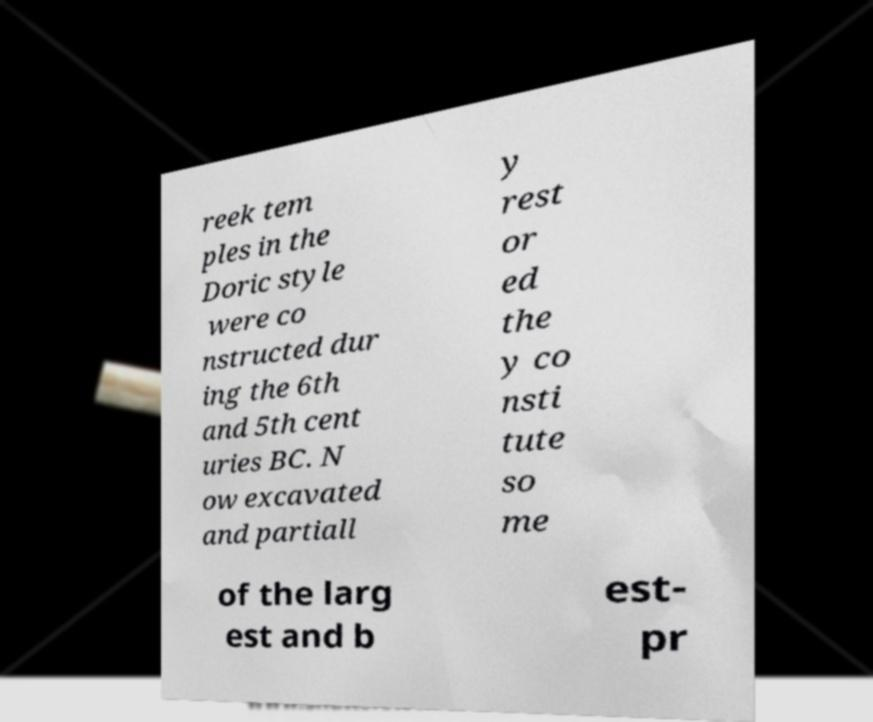Could you extract and type out the text from this image? reek tem ples in the Doric style were co nstructed dur ing the 6th and 5th cent uries BC. N ow excavated and partiall y rest or ed the y co nsti tute so me of the larg est and b est- pr 